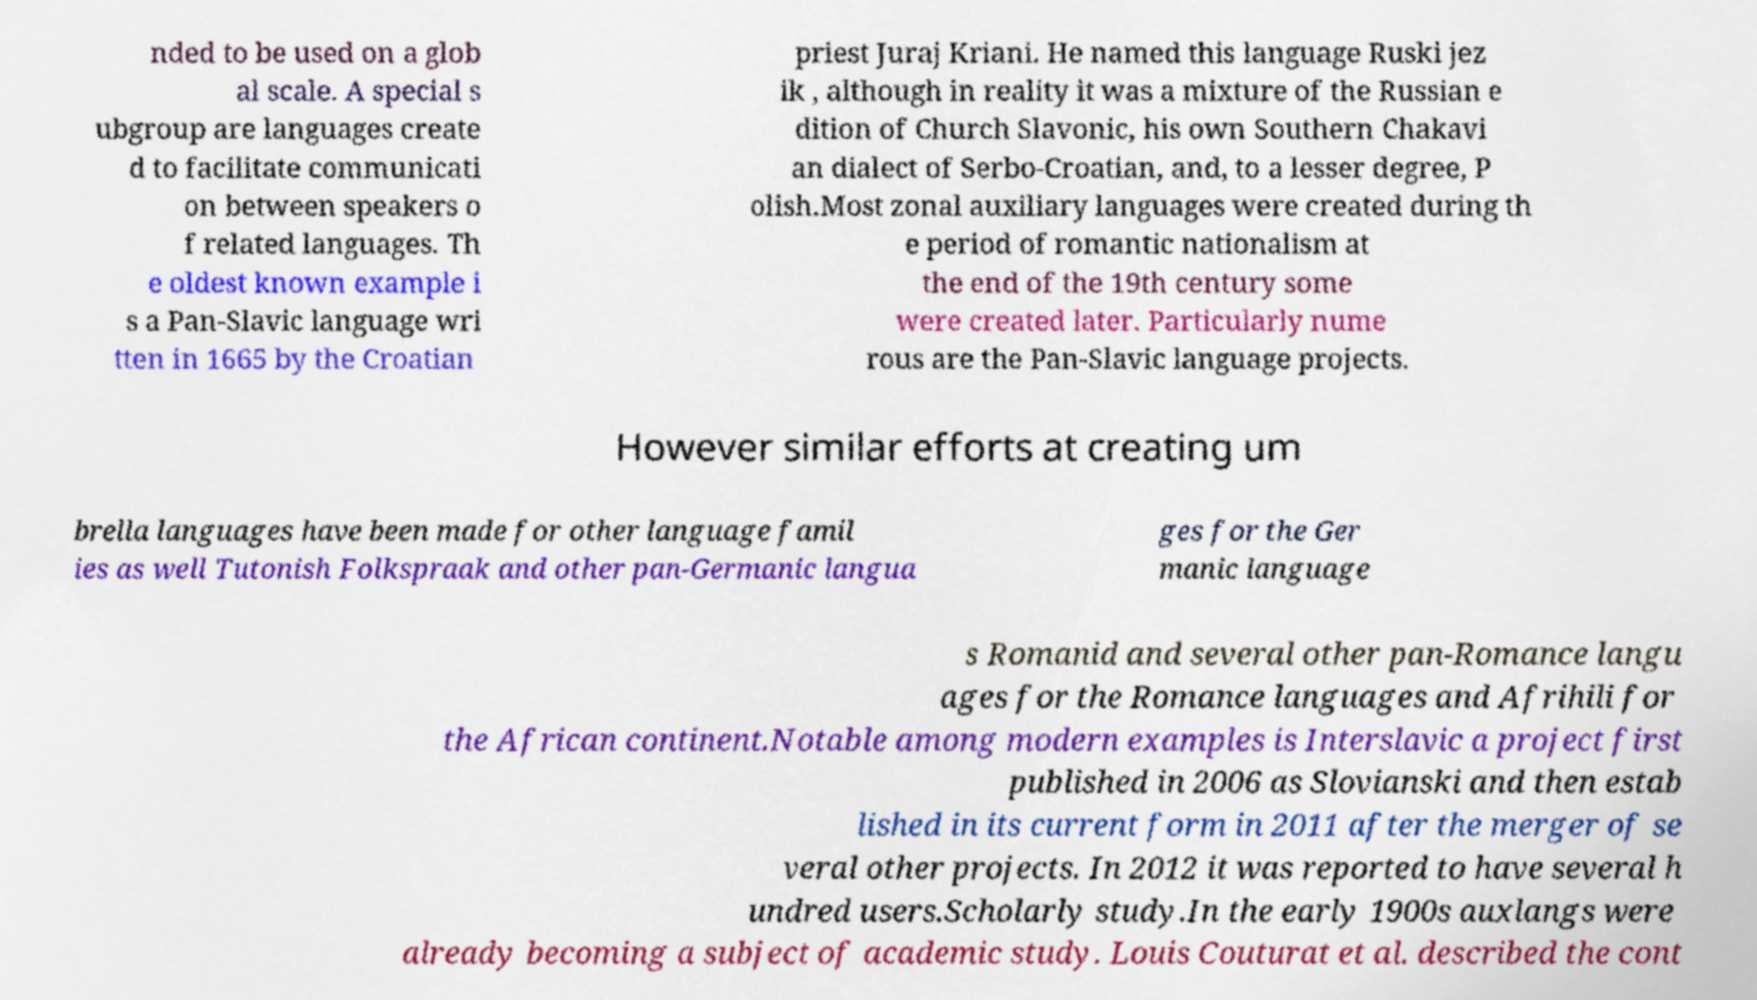For documentation purposes, I need the text within this image transcribed. Could you provide that? nded to be used on a glob al scale. A special s ubgroup are languages create d to facilitate communicati on between speakers o f related languages. Th e oldest known example i s a Pan-Slavic language wri tten in 1665 by the Croatian priest Juraj Kriani. He named this language Ruski jez ik , although in reality it was a mixture of the Russian e dition of Church Slavonic, his own Southern Chakavi an dialect of Serbo-Croatian, and, to a lesser degree, P olish.Most zonal auxiliary languages were created during th e period of romantic nationalism at the end of the 19th century some were created later. Particularly nume rous are the Pan-Slavic language projects. However similar efforts at creating um brella languages have been made for other language famil ies as well Tutonish Folkspraak and other pan-Germanic langua ges for the Ger manic language s Romanid and several other pan-Romance langu ages for the Romance languages and Afrihili for the African continent.Notable among modern examples is Interslavic a project first published in 2006 as Slovianski and then estab lished in its current form in 2011 after the merger of se veral other projects. In 2012 it was reported to have several h undred users.Scholarly study.In the early 1900s auxlangs were already becoming a subject of academic study. Louis Couturat et al. described the cont 